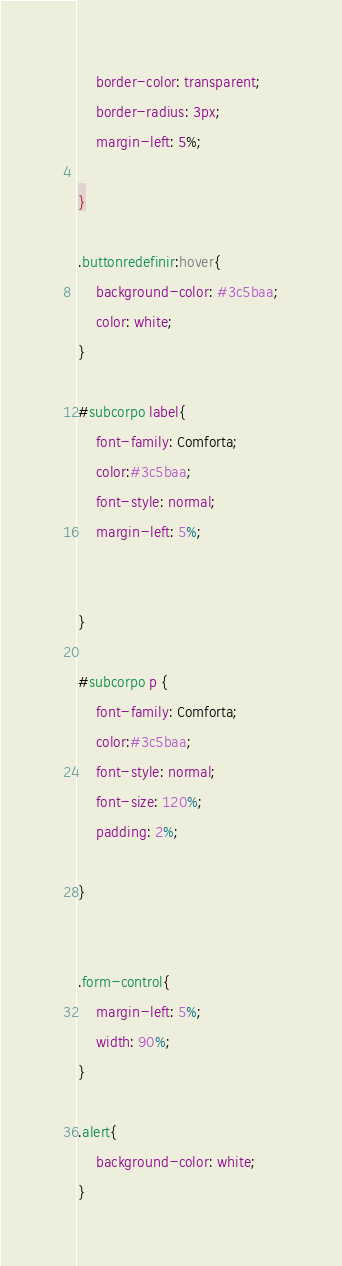<code> <loc_0><loc_0><loc_500><loc_500><_CSS_>    border-color: transparent;
    border-radius: 3px;
    margin-left: 5%;

}

.buttonredefinir:hover{
    background-color: #3c5baa;
    color: white;
}

#subcorpo label{
    font-family: Comforta;
    color:#3c5baa;
    font-style: normal;
    margin-left: 5%;
    
    
}

#subcorpo p {
    font-family: Comforta;
    color:#3c5baa;
    font-style: normal;
    font-size: 120%;
    padding: 2%;
 
}


.form-control{
    margin-left: 5%;
    width: 90%;
}

.alert{
    background-color: white;
}</code> 